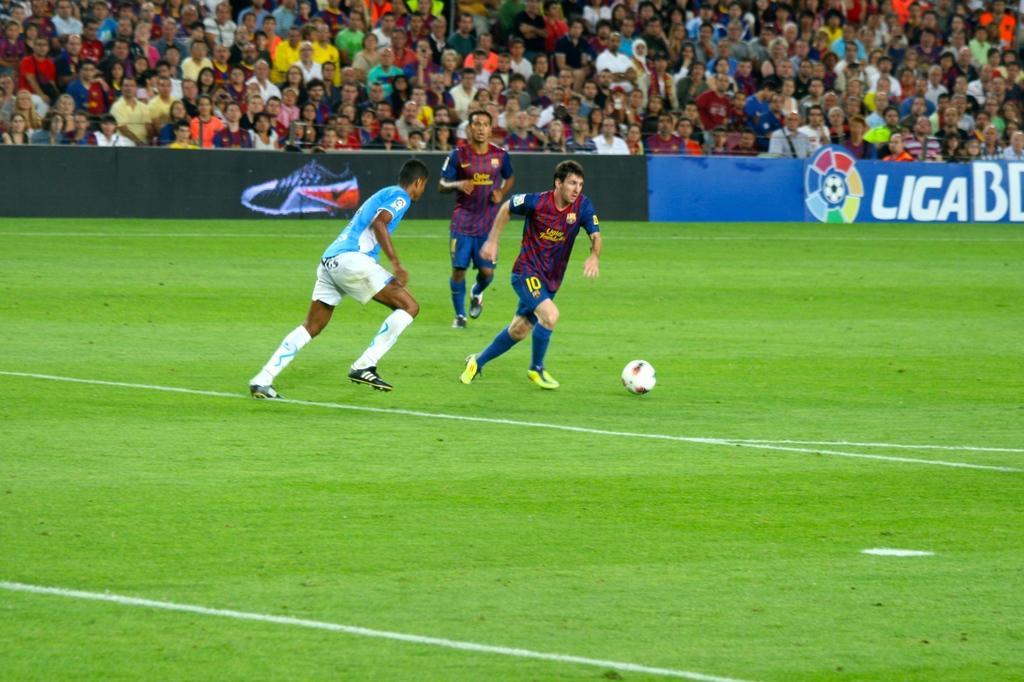Please provide a concise description of this image. In this image three players are playing on the ground. This is a football. There is boundary around the ground. On the gallery many people are sitting and watching the match. 